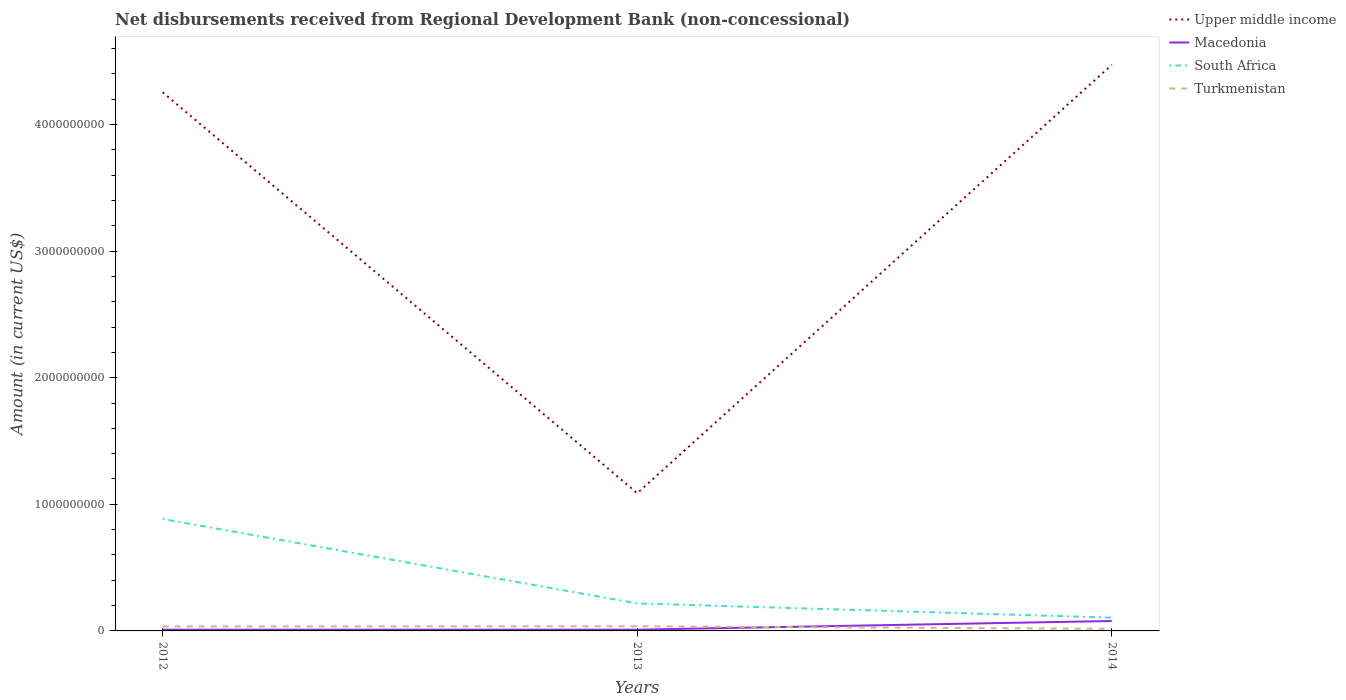How many different coloured lines are there?
Give a very brief answer. 4. Does the line corresponding to Upper middle income intersect with the line corresponding to South Africa?
Offer a very short reply. No. Is the number of lines equal to the number of legend labels?
Keep it short and to the point. Yes. Across all years, what is the maximum amount of disbursements received from Regional Development Bank in Macedonia?
Provide a succinct answer. 9.88e+06. What is the total amount of disbursements received from Regional Development Bank in Macedonia in the graph?
Provide a short and direct response. -6.85e+07. What is the difference between the highest and the second highest amount of disbursements received from Regional Development Bank in South Africa?
Give a very brief answer. 7.79e+08. Are the values on the major ticks of Y-axis written in scientific E-notation?
Offer a terse response. No. Does the graph contain grids?
Make the answer very short. No. Where does the legend appear in the graph?
Your response must be concise. Top right. How many legend labels are there?
Your answer should be very brief. 4. What is the title of the graph?
Provide a succinct answer. Net disbursements received from Regional Development Bank (non-concessional). What is the label or title of the X-axis?
Offer a terse response. Years. What is the Amount (in current US$) in Upper middle income in 2012?
Offer a terse response. 4.25e+09. What is the Amount (in current US$) in Macedonia in 2012?
Ensure brevity in your answer.  9.88e+06. What is the Amount (in current US$) of South Africa in 2012?
Provide a short and direct response. 8.84e+08. What is the Amount (in current US$) of Turkmenistan in 2012?
Offer a terse response. 3.51e+07. What is the Amount (in current US$) of Upper middle income in 2013?
Give a very brief answer. 1.09e+09. What is the Amount (in current US$) in Macedonia in 2013?
Offer a very short reply. 9.97e+06. What is the Amount (in current US$) in South Africa in 2013?
Provide a succinct answer. 2.17e+08. What is the Amount (in current US$) of Turkmenistan in 2013?
Offer a very short reply. 3.67e+07. What is the Amount (in current US$) in Upper middle income in 2014?
Provide a succinct answer. 4.47e+09. What is the Amount (in current US$) of Macedonia in 2014?
Give a very brief answer. 7.84e+07. What is the Amount (in current US$) in South Africa in 2014?
Your answer should be very brief. 1.05e+08. What is the Amount (in current US$) of Turkmenistan in 2014?
Your response must be concise. 1.67e+07. Across all years, what is the maximum Amount (in current US$) in Upper middle income?
Ensure brevity in your answer.  4.47e+09. Across all years, what is the maximum Amount (in current US$) in Macedonia?
Provide a short and direct response. 7.84e+07. Across all years, what is the maximum Amount (in current US$) of South Africa?
Provide a short and direct response. 8.84e+08. Across all years, what is the maximum Amount (in current US$) of Turkmenistan?
Your answer should be very brief. 3.67e+07. Across all years, what is the minimum Amount (in current US$) of Upper middle income?
Offer a terse response. 1.09e+09. Across all years, what is the minimum Amount (in current US$) in Macedonia?
Give a very brief answer. 9.88e+06. Across all years, what is the minimum Amount (in current US$) of South Africa?
Keep it short and to the point. 1.05e+08. Across all years, what is the minimum Amount (in current US$) in Turkmenistan?
Keep it short and to the point. 1.67e+07. What is the total Amount (in current US$) of Upper middle income in the graph?
Offer a terse response. 9.81e+09. What is the total Amount (in current US$) in Macedonia in the graph?
Provide a short and direct response. 9.82e+07. What is the total Amount (in current US$) of South Africa in the graph?
Your answer should be compact. 1.21e+09. What is the total Amount (in current US$) of Turkmenistan in the graph?
Make the answer very short. 8.85e+07. What is the difference between the Amount (in current US$) in Upper middle income in 2012 and that in 2013?
Provide a succinct answer. 3.17e+09. What is the difference between the Amount (in current US$) in Macedonia in 2012 and that in 2013?
Your answer should be very brief. -8.50e+04. What is the difference between the Amount (in current US$) of South Africa in 2012 and that in 2013?
Provide a short and direct response. 6.67e+08. What is the difference between the Amount (in current US$) of Turkmenistan in 2012 and that in 2013?
Your answer should be compact. -1.55e+06. What is the difference between the Amount (in current US$) in Upper middle income in 2012 and that in 2014?
Make the answer very short. -2.17e+08. What is the difference between the Amount (in current US$) in Macedonia in 2012 and that in 2014?
Your answer should be very brief. -6.85e+07. What is the difference between the Amount (in current US$) of South Africa in 2012 and that in 2014?
Provide a short and direct response. 7.79e+08. What is the difference between the Amount (in current US$) in Turkmenistan in 2012 and that in 2014?
Keep it short and to the point. 1.85e+07. What is the difference between the Amount (in current US$) in Upper middle income in 2013 and that in 2014?
Your answer should be very brief. -3.38e+09. What is the difference between the Amount (in current US$) of Macedonia in 2013 and that in 2014?
Provide a succinct answer. -6.84e+07. What is the difference between the Amount (in current US$) of South Africa in 2013 and that in 2014?
Ensure brevity in your answer.  1.13e+08. What is the difference between the Amount (in current US$) in Turkmenistan in 2013 and that in 2014?
Offer a terse response. 2.00e+07. What is the difference between the Amount (in current US$) of Upper middle income in 2012 and the Amount (in current US$) of Macedonia in 2013?
Your answer should be very brief. 4.24e+09. What is the difference between the Amount (in current US$) in Upper middle income in 2012 and the Amount (in current US$) in South Africa in 2013?
Your response must be concise. 4.04e+09. What is the difference between the Amount (in current US$) of Upper middle income in 2012 and the Amount (in current US$) of Turkmenistan in 2013?
Ensure brevity in your answer.  4.22e+09. What is the difference between the Amount (in current US$) in Macedonia in 2012 and the Amount (in current US$) in South Africa in 2013?
Provide a succinct answer. -2.08e+08. What is the difference between the Amount (in current US$) of Macedonia in 2012 and the Amount (in current US$) of Turkmenistan in 2013?
Keep it short and to the point. -2.68e+07. What is the difference between the Amount (in current US$) of South Africa in 2012 and the Amount (in current US$) of Turkmenistan in 2013?
Offer a terse response. 8.47e+08. What is the difference between the Amount (in current US$) in Upper middle income in 2012 and the Amount (in current US$) in Macedonia in 2014?
Provide a succinct answer. 4.18e+09. What is the difference between the Amount (in current US$) of Upper middle income in 2012 and the Amount (in current US$) of South Africa in 2014?
Keep it short and to the point. 4.15e+09. What is the difference between the Amount (in current US$) in Upper middle income in 2012 and the Amount (in current US$) in Turkmenistan in 2014?
Keep it short and to the point. 4.24e+09. What is the difference between the Amount (in current US$) in Macedonia in 2012 and the Amount (in current US$) in South Africa in 2014?
Your answer should be very brief. -9.50e+07. What is the difference between the Amount (in current US$) in Macedonia in 2012 and the Amount (in current US$) in Turkmenistan in 2014?
Ensure brevity in your answer.  -6.81e+06. What is the difference between the Amount (in current US$) in South Africa in 2012 and the Amount (in current US$) in Turkmenistan in 2014?
Provide a short and direct response. 8.67e+08. What is the difference between the Amount (in current US$) of Upper middle income in 2013 and the Amount (in current US$) of Macedonia in 2014?
Ensure brevity in your answer.  1.01e+09. What is the difference between the Amount (in current US$) in Upper middle income in 2013 and the Amount (in current US$) in South Africa in 2014?
Keep it short and to the point. 9.83e+08. What is the difference between the Amount (in current US$) in Upper middle income in 2013 and the Amount (in current US$) in Turkmenistan in 2014?
Your answer should be very brief. 1.07e+09. What is the difference between the Amount (in current US$) of Macedonia in 2013 and the Amount (in current US$) of South Africa in 2014?
Keep it short and to the point. -9.49e+07. What is the difference between the Amount (in current US$) of Macedonia in 2013 and the Amount (in current US$) of Turkmenistan in 2014?
Offer a very short reply. -6.72e+06. What is the difference between the Amount (in current US$) in South Africa in 2013 and the Amount (in current US$) in Turkmenistan in 2014?
Give a very brief answer. 2.01e+08. What is the average Amount (in current US$) of Upper middle income per year?
Make the answer very short. 3.27e+09. What is the average Amount (in current US$) of Macedonia per year?
Give a very brief answer. 3.27e+07. What is the average Amount (in current US$) in South Africa per year?
Offer a terse response. 4.02e+08. What is the average Amount (in current US$) in Turkmenistan per year?
Your response must be concise. 2.95e+07. In the year 2012, what is the difference between the Amount (in current US$) of Upper middle income and Amount (in current US$) of Macedonia?
Your response must be concise. 4.24e+09. In the year 2012, what is the difference between the Amount (in current US$) of Upper middle income and Amount (in current US$) of South Africa?
Ensure brevity in your answer.  3.37e+09. In the year 2012, what is the difference between the Amount (in current US$) of Upper middle income and Amount (in current US$) of Turkmenistan?
Keep it short and to the point. 4.22e+09. In the year 2012, what is the difference between the Amount (in current US$) in Macedonia and Amount (in current US$) in South Africa?
Make the answer very short. -8.74e+08. In the year 2012, what is the difference between the Amount (in current US$) of Macedonia and Amount (in current US$) of Turkmenistan?
Provide a succinct answer. -2.53e+07. In the year 2012, what is the difference between the Amount (in current US$) in South Africa and Amount (in current US$) in Turkmenistan?
Ensure brevity in your answer.  8.49e+08. In the year 2013, what is the difference between the Amount (in current US$) of Upper middle income and Amount (in current US$) of Macedonia?
Ensure brevity in your answer.  1.08e+09. In the year 2013, what is the difference between the Amount (in current US$) of Upper middle income and Amount (in current US$) of South Africa?
Provide a succinct answer. 8.70e+08. In the year 2013, what is the difference between the Amount (in current US$) in Upper middle income and Amount (in current US$) in Turkmenistan?
Keep it short and to the point. 1.05e+09. In the year 2013, what is the difference between the Amount (in current US$) of Macedonia and Amount (in current US$) of South Africa?
Make the answer very short. -2.07e+08. In the year 2013, what is the difference between the Amount (in current US$) of Macedonia and Amount (in current US$) of Turkmenistan?
Ensure brevity in your answer.  -2.67e+07. In the year 2013, what is the difference between the Amount (in current US$) in South Africa and Amount (in current US$) in Turkmenistan?
Provide a succinct answer. 1.81e+08. In the year 2014, what is the difference between the Amount (in current US$) of Upper middle income and Amount (in current US$) of Macedonia?
Ensure brevity in your answer.  4.39e+09. In the year 2014, what is the difference between the Amount (in current US$) of Upper middle income and Amount (in current US$) of South Africa?
Provide a succinct answer. 4.37e+09. In the year 2014, what is the difference between the Amount (in current US$) of Upper middle income and Amount (in current US$) of Turkmenistan?
Keep it short and to the point. 4.45e+09. In the year 2014, what is the difference between the Amount (in current US$) of Macedonia and Amount (in current US$) of South Africa?
Your response must be concise. -2.65e+07. In the year 2014, what is the difference between the Amount (in current US$) of Macedonia and Amount (in current US$) of Turkmenistan?
Your answer should be compact. 6.17e+07. In the year 2014, what is the difference between the Amount (in current US$) of South Africa and Amount (in current US$) of Turkmenistan?
Offer a terse response. 8.82e+07. What is the ratio of the Amount (in current US$) in Upper middle income in 2012 to that in 2013?
Keep it short and to the point. 3.91. What is the ratio of the Amount (in current US$) in Macedonia in 2012 to that in 2013?
Ensure brevity in your answer.  0.99. What is the ratio of the Amount (in current US$) of South Africa in 2012 to that in 2013?
Keep it short and to the point. 4.07. What is the ratio of the Amount (in current US$) in Turkmenistan in 2012 to that in 2013?
Offer a very short reply. 0.96. What is the ratio of the Amount (in current US$) in Upper middle income in 2012 to that in 2014?
Give a very brief answer. 0.95. What is the ratio of the Amount (in current US$) of Macedonia in 2012 to that in 2014?
Make the answer very short. 0.13. What is the ratio of the Amount (in current US$) in South Africa in 2012 to that in 2014?
Offer a terse response. 8.43. What is the ratio of the Amount (in current US$) of Turkmenistan in 2012 to that in 2014?
Keep it short and to the point. 2.11. What is the ratio of the Amount (in current US$) of Upper middle income in 2013 to that in 2014?
Provide a short and direct response. 0.24. What is the ratio of the Amount (in current US$) in Macedonia in 2013 to that in 2014?
Your answer should be very brief. 0.13. What is the ratio of the Amount (in current US$) of South Africa in 2013 to that in 2014?
Keep it short and to the point. 2.07. What is the ratio of the Amount (in current US$) of Turkmenistan in 2013 to that in 2014?
Your answer should be compact. 2.2. What is the difference between the highest and the second highest Amount (in current US$) of Upper middle income?
Provide a succinct answer. 2.17e+08. What is the difference between the highest and the second highest Amount (in current US$) of Macedonia?
Your answer should be very brief. 6.84e+07. What is the difference between the highest and the second highest Amount (in current US$) in South Africa?
Give a very brief answer. 6.67e+08. What is the difference between the highest and the second highest Amount (in current US$) in Turkmenistan?
Give a very brief answer. 1.55e+06. What is the difference between the highest and the lowest Amount (in current US$) of Upper middle income?
Ensure brevity in your answer.  3.38e+09. What is the difference between the highest and the lowest Amount (in current US$) in Macedonia?
Offer a very short reply. 6.85e+07. What is the difference between the highest and the lowest Amount (in current US$) in South Africa?
Provide a short and direct response. 7.79e+08. What is the difference between the highest and the lowest Amount (in current US$) of Turkmenistan?
Your response must be concise. 2.00e+07. 